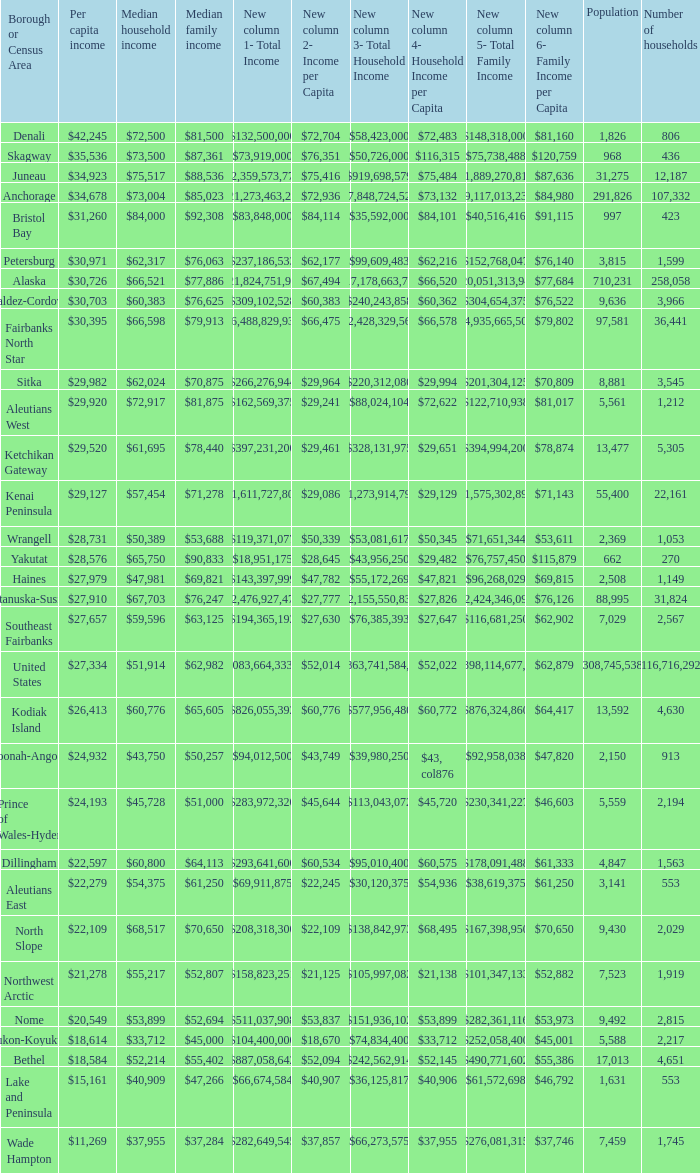Which borough or census area has a $59,596 median household income? Southeast Fairbanks. 